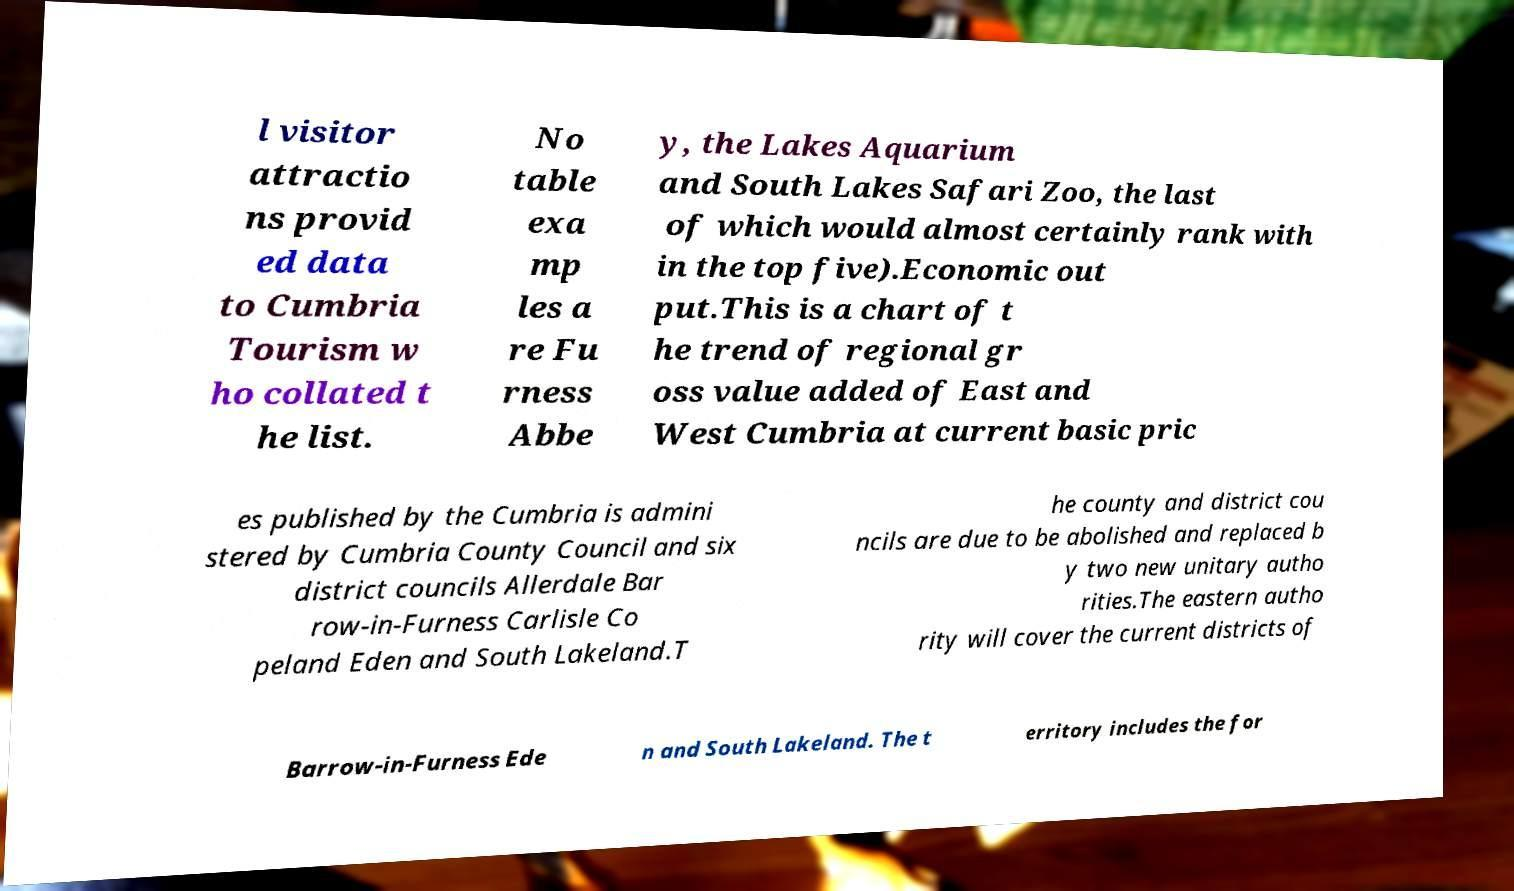Please identify and transcribe the text found in this image. l visitor attractio ns provid ed data to Cumbria Tourism w ho collated t he list. No table exa mp les a re Fu rness Abbe y, the Lakes Aquarium and South Lakes Safari Zoo, the last of which would almost certainly rank with in the top five).Economic out put.This is a chart of t he trend of regional gr oss value added of East and West Cumbria at current basic pric es published by the Cumbria is admini stered by Cumbria County Council and six district councils Allerdale Bar row-in-Furness Carlisle Co peland Eden and South Lakeland.T he county and district cou ncils are due to be abolished and replaced b y two new unitary autho rities.The eastern autho rity will cover the current districts of Barrow-in-Furness Ede n and South Lakeland. The t erritory includes the for 